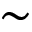Convert formula to latex. <formula><loc_0><loc_0><loc_500><loc_500>\sim</formula> 